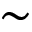Convert formula to latex. <formula><loc_0><loc_0><loc_500><loc_500>\sim</formula> 